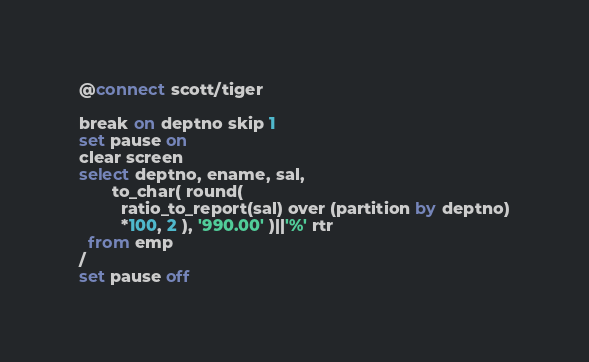<code> <loc_0><loc_0><loc_500><loc_500><_SQL_>@connect scott/tiger

break on deptno skip 1
set pause on
clear screen
select deptno, ename, sal, 
       to_char( round( 
	     ratio_to_report(sal) over (partition by deptno)
		 *100, 2 ), '990.00' )||'%' rtr
  from emp
/
set pause off
</code> 